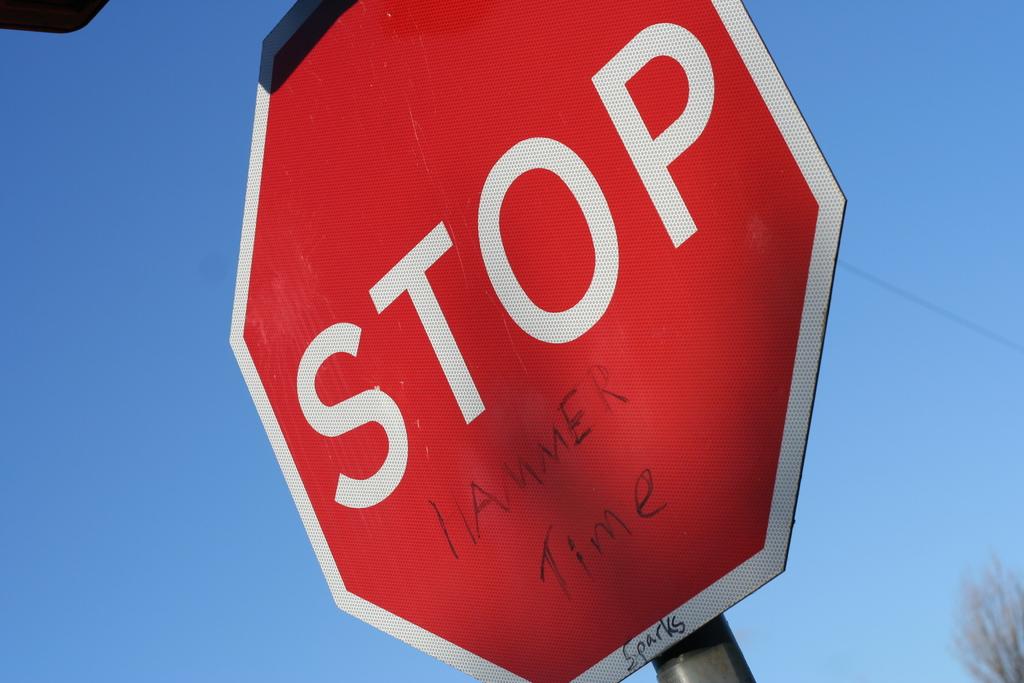What did they write on the stop sign?
Offer a very short reply. Hammer time. 